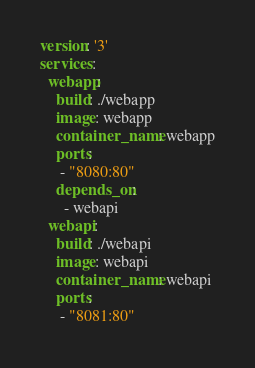Convert code to text. <code><loc_0><loc_0><loc_500><loc_500><_YAML_>version: '3'
services:
  webapp:
    build: ./webapp
    image: webapp
    container_name: webapp
    ports:
     - "8080:80"
    depends_on:
      - webapi
  webapi:
    build: ./webapi
    image: webapi
    container_name: webapi
    ports:
     - "8081:80"</code> 